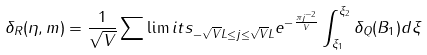Convert formula to latex. <formula><loc_0><loc_0><loc_500><loc_500>\delta _ { R } ( \eta , m ) = \frac { 1 } { \sqrt { V } } \sum \lim i t s _ { - \sqrt { V } L \leq j \leq \sqrt { V } L } e ^ { - \frac { \pi j ^ { - 2 } } { V } } \int _ { \xi _ { 1 } } ^ { \xi _ { 2 } } \delta _ { Q } ( B _ { 1 } ) d \xi</formula> 